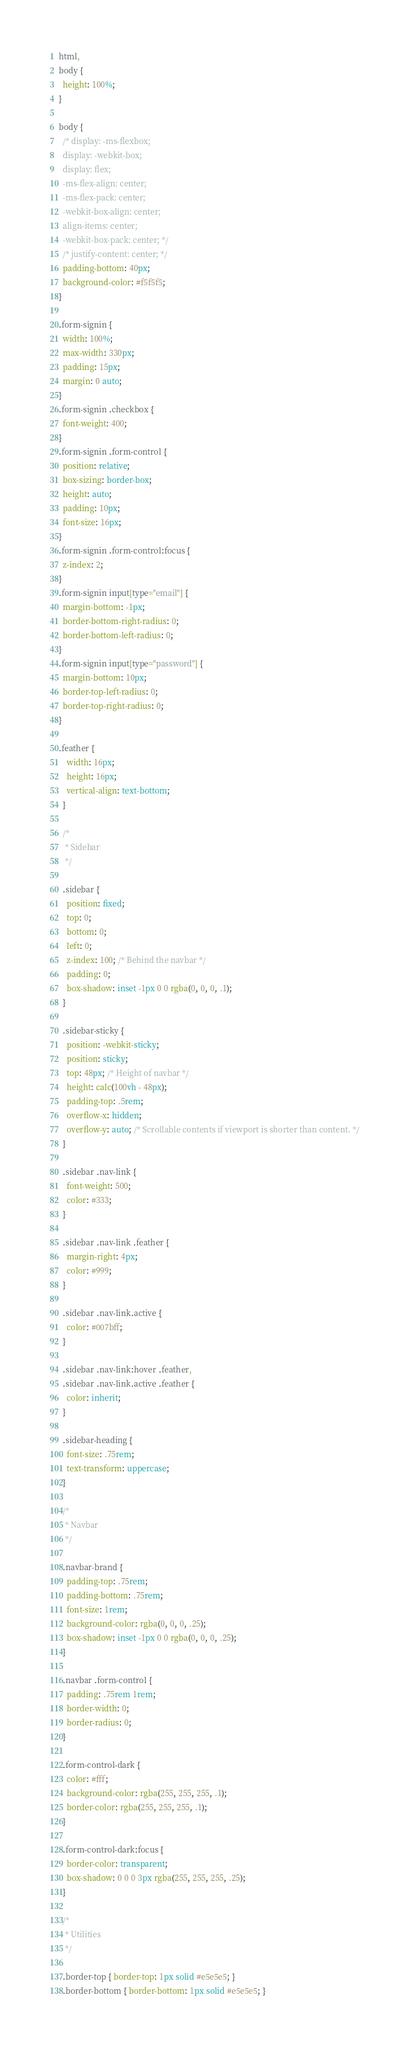Convert code to text. <code><loc_0><loc_0><loc_500><loc_500><_CSS_>html,
body {
  height: 100%;
}

body {
  /* display: -ms-flexbox;
  display: -webkit-box;
  display: flex;
  -ms-flex-align: center;
  -ms-flex-pack: center;
  -webkit-box-align: center;
  align-items: center;
  -webkit-box-pack: center; */
  /* justify-content: center; */
  padding-bottom: 40px;
  background-color: #f5f5f5;
}

.form-signin {
  width: 100%;
  max-width: 330px;
  padding: 15px;
  margin: 0 auto;
}
.form-signin .checkbox {
  font-weight: 400;
}
.form-signin .form-control {
  position: relative;
  box-sizing: border-box;
  height: auto;
  padding: 10px;
  font-size: 16px;
}
.form-signin .form-control:focus {
  z-index: 2;
}
.form-signin input[type="email"] {
  margin-bottom: -1px;
  border-bottom-right-radius: 0;
  border-bottom-left-radius: 0;
}
.form-signin input[type="password"] {
  margin-bottom: 10px;
  border-top-left-radius: 0;
  border-top-right-radius: 0;
}

.feather {
    width: 16px;
    height: 16px;
    vertical-align: text-bottom;
  }

  /*
   * Sidebar
   */

  .sidebar {
    position: fixed;
    top: 0;
    bottom: 0;
    left: 0;
    z-index: 100; /* Behind the navbar */
    padding: 0;
    box-shadow: inset -1px 0 0 rgba(0, 0, 0, .1);
  }

  .sidebar-sticky {
    position: -webkit-sticky;
    position: sticky;
    top: 48px; /* Height of navbar */
    height: calc(100vh - 48px);
    padding-top: .5rem;
    overflow-x: hidden;
    overflow-y: auto; /* Scrollable contents if viewport is shorter than content. */
  }

  .sidebar .nav-link {
    font-weight: 500;
    color: #333;
  }

  .sidebar .nav-link .feather {
    margin-right: 4px;
    color: #999;
  }

  .sidebar .nav-link.active {
    color: #007bff;
  }

  .sidebar .nav-link:hover .feather,
  .sidebar .nav-link.active .feather {
    color: inherit;
  }

  .sidebar-heading {
    font-size: .75rem;
    text-transform: uppercase;
  }

  /*
   * Navbar
   */

  .navbar-brand {
    padding-top: .75rem;
    padding-bottom: .75rem;
    font-size: 1rem;
    background-color: rgba(0, 0, 0, .25);
    box-shadow: inset -1px 0 0 rgba(0, 0, 0, .25);
  }

  .navbar .form-control {
    padding: .75rem 1rem;
    border-width: 0;
    border-radius: 0;
  }

  .form-control-dark {
    color: #fff;
    background-color: rgba(255, 255, 255, .1);
    border-color: rgba(255, 255, 255, .1);
  }

  .form-control-dark:focus {
    border-color: transparent;
    box-shadow: 0 0 0 3px rgba(255, 255, 255, .25);
  }

  /*
   * Utilities
   */

  .border-top { border-top: 1px solid #e5e5e5; }
  .border-bottom { border-bottom: 1px solid #e5e5e5; }
</code> 